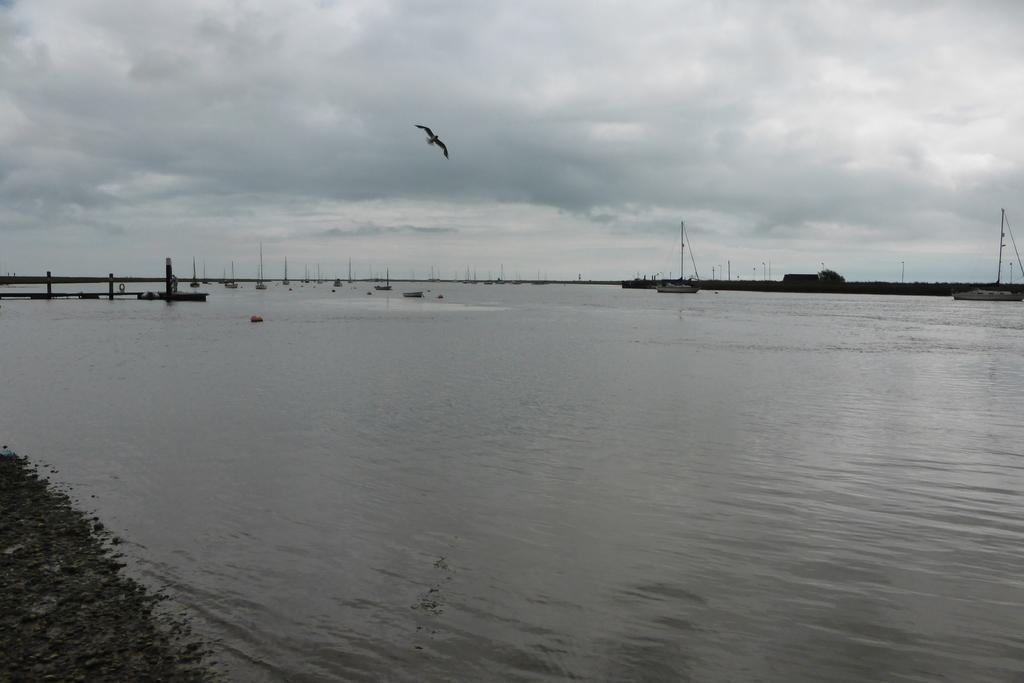What is happening on the water in the image? There are boats on the water in the image. What can be seen in the background of the image? There is a boatyard and the sky visible in the background of the image. Are there any other objects present in the background of the image? Yes, there are other objects present in the background of the image. What language is spoken by the egg in the image? There is no egg present in the image, so it is not possible to determine what language it might speak. 